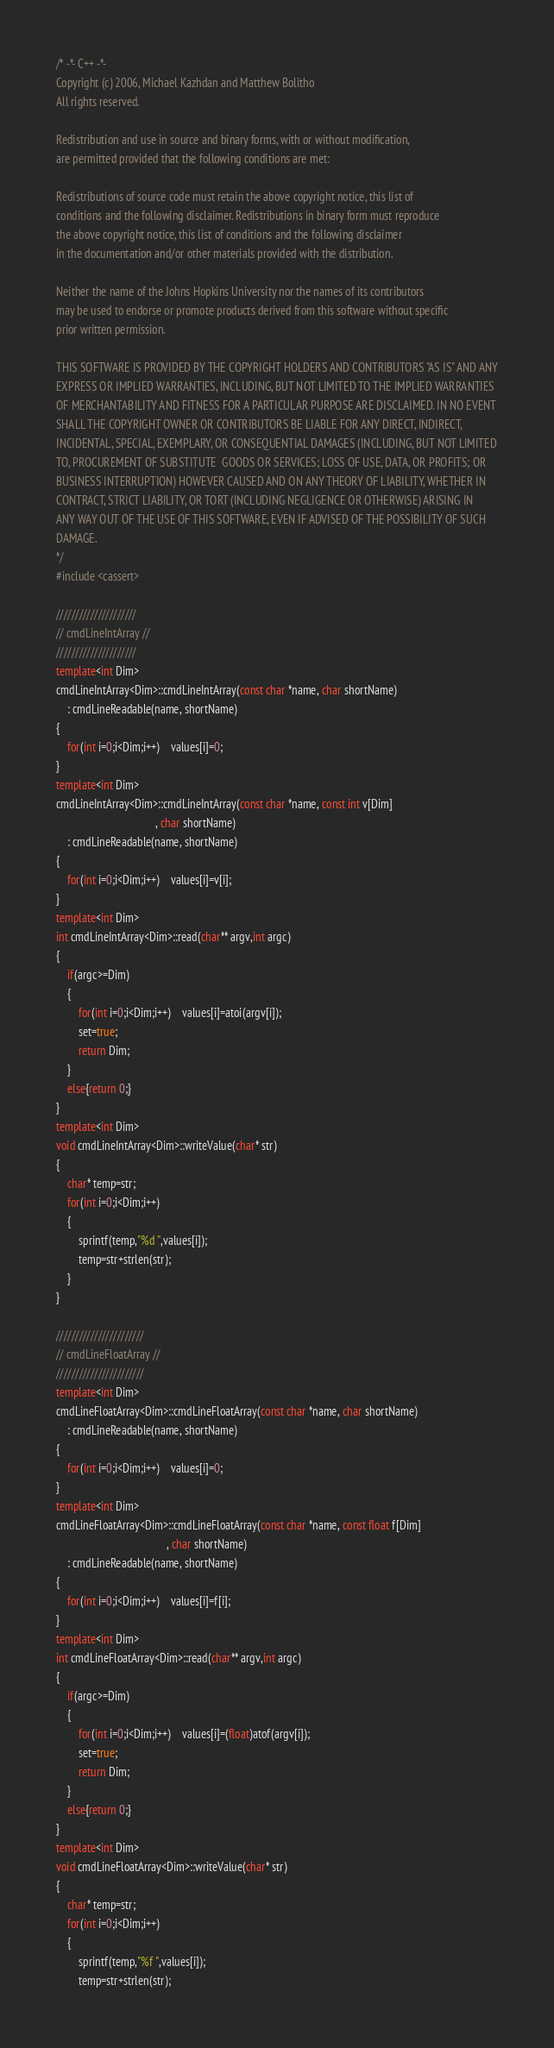<code> <loc_0><loc_0><loc_500><loc_500><_C++_>/* -*- C++ -*-
Copyright (c) 2006, Michael Kazhdan and Matthew Bolitho
All rights reserved.

Redistribution and use in source and binary forms, with or without modification,
are permitted provided that the following conditions are met:

Redistributions of source code must retain the above copyright notice, this list of
conditions and the following disclaimer. Redistributions in binary form must reproduce
the above copyright notice, this list of conditions and the following disclaimer
in the documentation and/or other materials provided with the distribution. 

Neither the name of the Johns Hopkins University nor the names of its contributors
may be used to endorse or promote products derived from this software without specific
prior written permission. 

THIS SOFTWARE IS PROVIDED BY THE COPYRIGHT HOLDERS AND CONTRIBUTORS "AS IS" AND ANY
EXPRESS OR IMPLIED WARRANTIES, INCLUDING, BUT NOT LIMITED TO THE IMPLIED WARRANTIES 
OF MERCHANTABILITY AND FITNESS FOR A PARTICULAR PURPOSE ARE DISCLAIMED. IN NO EVENT
SHALL THE COPYRIGHT OWNER OR CONTRIBUTORS BE LIABLE FOR ANY DIRECT, INDIRECT,
INCIDENTAL, SPECIAL, EXEMPLARY, OR CONSEQUENTIAL DAMAGES (INCLUDING, BUT NOT LIMITED
TO, PROCUREMENT OF SUBSTITUTE  GOODS OR SERVICES; LOSS OF USE, DATA, OR PROFITS; OR
BUSINESS INTERRUPTION) HOWEVER CAUSED AND ON ANY THEORY OF LIABILITY, WHETHER IN
CONTRACT, STRICT LIABILITY, OR TORT (INCLUDING NEGLIGENCE OR OTHERWISE) ARISING IN
ANY WAY OUT OF THE USE OF THIS SOFTWARE, EVEN IF ADVISED OF THE POSSIBILITY OF SUCH
DAMAGE.
*/
#include <cassert>

/////////////////////
// cmdLineIntArray //
/////////////////////
template<int Dim>
cmdLineIntArray<Dim>::cmdLineIntArray(const char *name, char shortName)
    : cmdLineReadable(name, shortName)
{
	for(int i=0;i<Dim;i++)	values[i]=0;
}
template<int Dim>
cmdLineIntArray<Dim>::cmdLineIntArray(const char *name, const int v[Dim]
                                    , char shortName)
    : cmdLineReadable(name, shortName)
{
	for(int i=0;i<Dim;i++)	values[i]=v[i];
}
template<int Dim>
int cmdLineIntArray<Dim>::read(char** argv,int argc)
{
	if(argc>=Dim)
	{
		for(int i=0;i<Dim;i++)	values[i]=atoi(argv[i]);
		set=true;
		return Dim;
	}
	else{return 0;}
}
template<int Dim>
void cmdLineIntArray<Dim>::writeValue(char* str)
{
	char* temp=str;
	for(int i=0;i<Dim;i++)
	{
		sprintf(temp,"%d ",values[i]);
		temp=str+strlen(str);
	}
}

///////////////////////
// cmdLineFloatArray //
///////////////////////
template<int Dim>
cmdLineFloatArray<Dim>::cmdLineFloatArray(const char *name, char shortName)
    : cmdLineReadable(name, shortName)
{
	for(int i=0;i<Dim;i++)	values[i]=0;
}
template<int Dim>
cmdLineFloatArray<Dim>::cmdLineFloatArray(const char *name, const float f[Dim]
                                        , char shortName)
    : cmdLineReadable(name, shortName)
{
	for(int i=0;i<Dim;i++)	values[i]=f[i];
}
template<int Dim>
int cmdLineFloatArray<Dim>::read(char** argv,int argc)
{
	if(argc>=Dim)
	{
		for(int i=0;i<Dim;i++)	values[i]=(float)atof(argv[i]);
		set=true;
		return Dim;
	}
	else{return 0;}
}
template<int Dim>
void cmdLineFloatArray<Dim>::writeValue(char* str)
{
	char* temp=str;
	for(int i=0;i<Dim;i++)
	{
		sprintf(temp,"%f ",values[i]);
		temp=str+strlen(str);</code> 